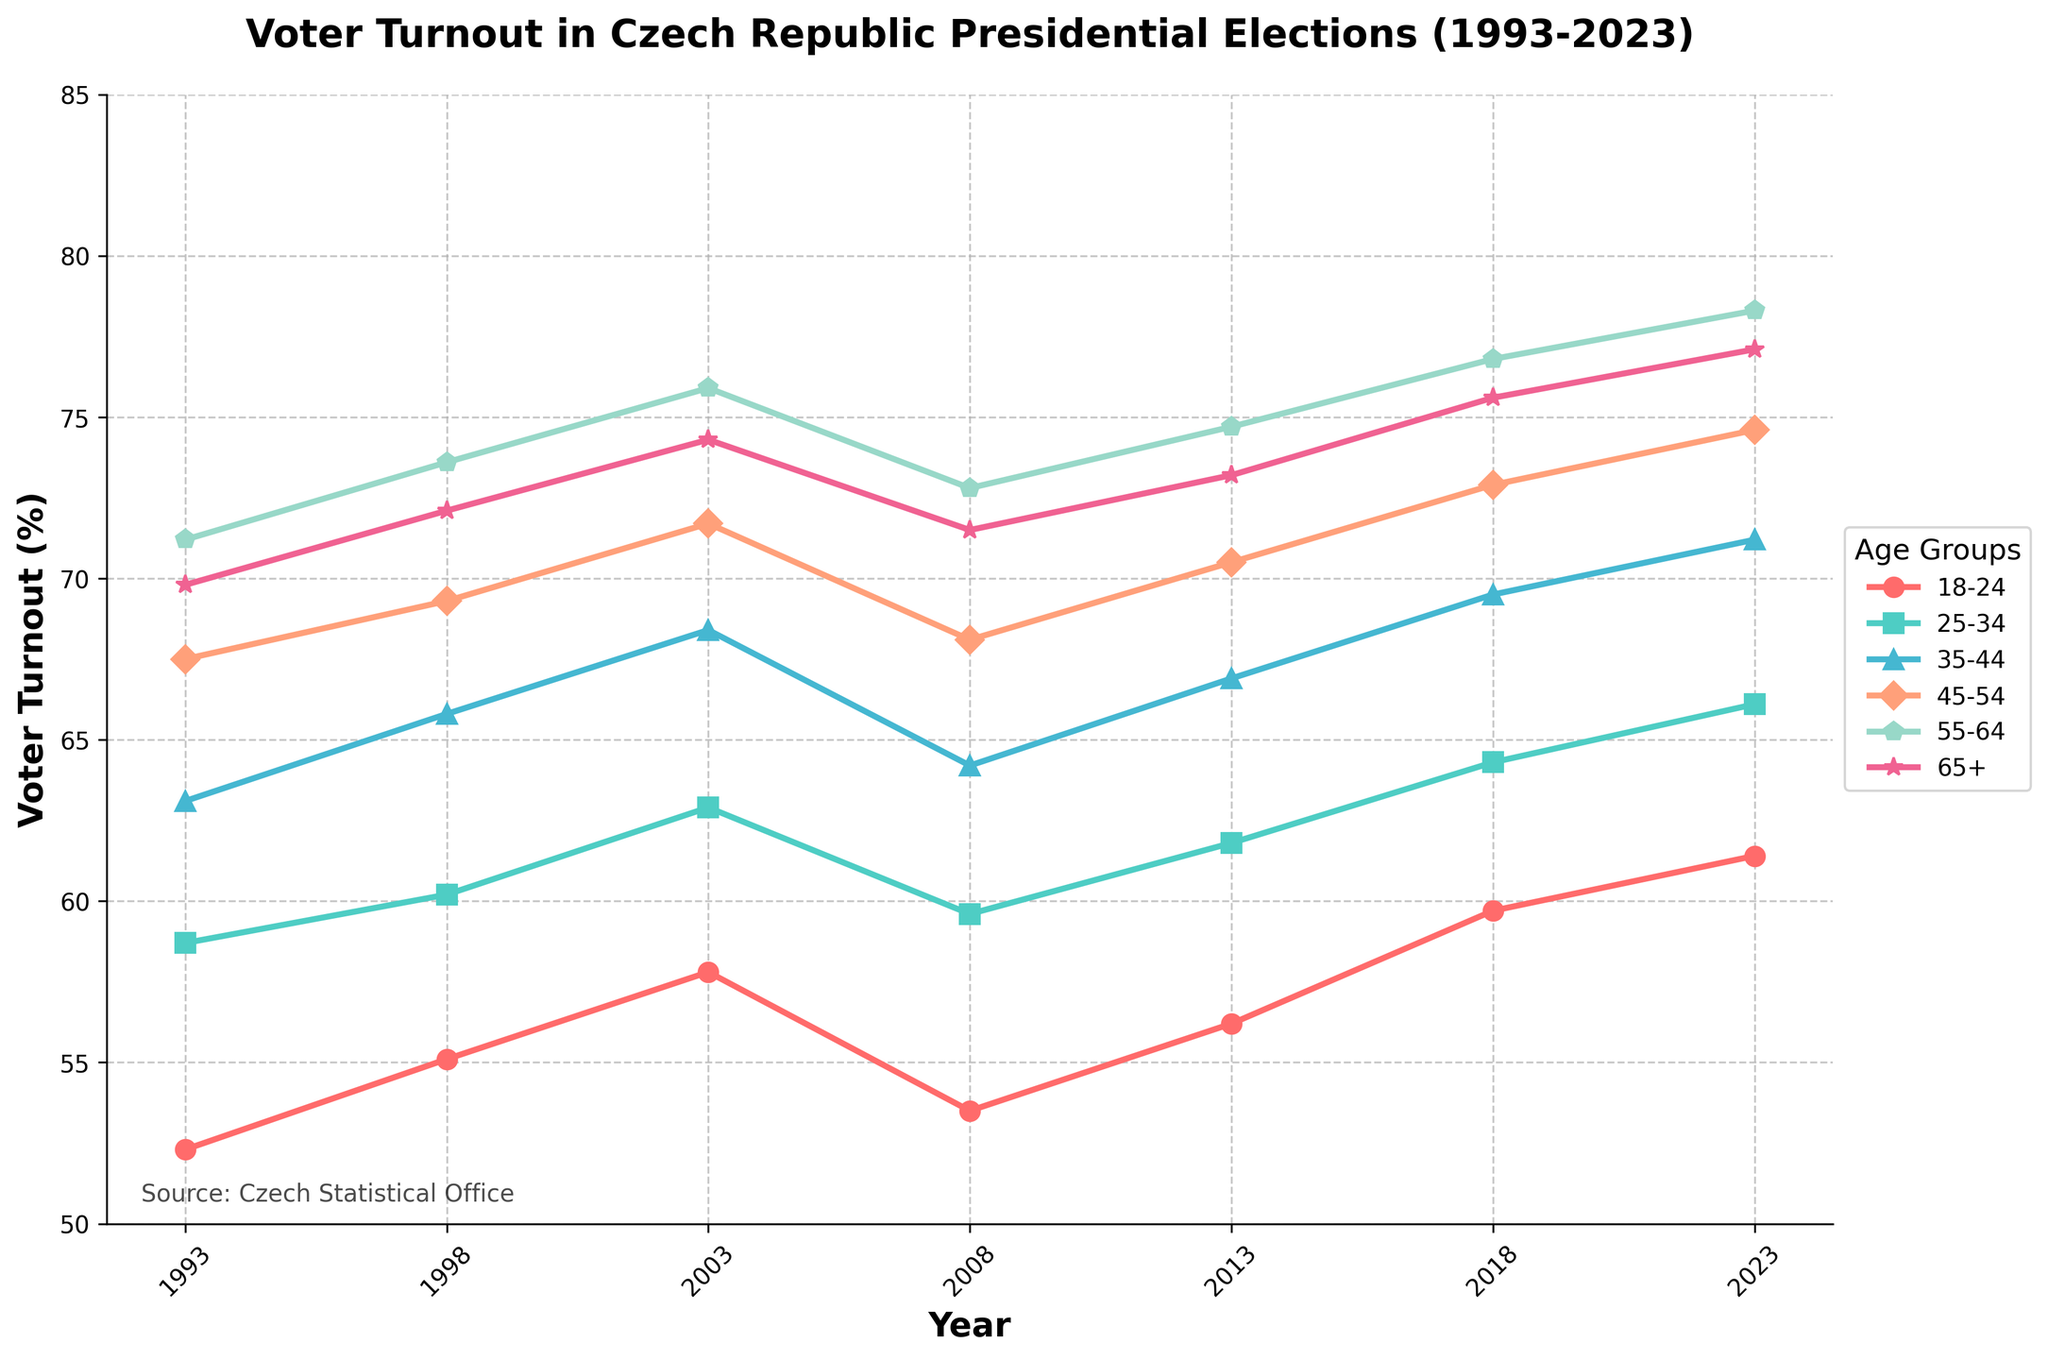What's the trend in voter turnout for the 18-24 age group from 1993 to 2023? The trend can be observed by looking at the plotted points for the 18-24 age group across the years. The turnout starts at 52.3% in 1993, increases to 61.4% by 2023. This indicates an overall upward trend despite some fluctuations.
Answer: Upward trend Between which years did the 55-64 age group see the largest increase in voter turnout? By comparing the increase in percentages year-by-year for the 55-64 age group, the biggest jump can be observed between 2008 (72.8%) and 2013 (74.7%), resulting in an increase of 1.9 percentage points.
Answer: Between 2008 and 2013 What's the average voter turnout for the 65+ age group from 1993 to 2023? To find the average, add the voter turnout percentages for the 65+ age group for each election year (69.8 + 72.1 + 74.3 + 71.5 + 73.2 + 75.6 + 77.1) and then divide by the number of years (7). The calculation is 513.6 / 7 = 73.37%.
Answer: 73.37% Which age group had the lowest voter turnout in 2013? By looking at the 2013 data points for each age group, the 18-24 age group had the lowest voter turnout at 56.2%.
Answer: 18-24 age group Compare the voter turnout between the 35-44 and 45-54 age groups in 1998. Which group had a higher turnout and by how much? In 1998, the voter turnout for the 35-44 age group was 65.8%, and for the 45-54 age group, it was 69.3%. The difference is 69.3% - 65.8% = 3.5%. Therefore, the 45-54 age group had a higher turnout by 3.5%.
Answer: 45-54 by 3.5% How does the voter turnout for the 25-34 age group in 2023 compare to the 55-64 age group in 2003? The voter turnout for the 25-34 age group in 2023 is 66.1%, while for the 55-64 age group in 2003, it is 75.9%. Comparatively, the 55-64 age group in 2003 had a higher turnout by 9.8 percentage points.
Answer: 55-64 in 2003 had a higher turnout by 9.8% From the visual perspective, which age group consistently shows the highest voter turnout between 1993 and 2023? By observing the top-most lines in the plot throughout the years, the 65+ age group consistently shows the highest voter turnout.
Answer: 65+ age group In which election year did the 18-24 age group experience a decline in voter turnout compared to the previous election? By checking the data points for each election year, the 18-24 age group experienced a decline in voter turnout from 2003 (57.8%) to 2008 (53.5%).
Answer: 2008 What is the median voter turnout percentage for all age groups in 2023? List the voter turnout percentages for all age groups in 2023, which are: 61.4%, 66.1%, 71.2%, 74.6%, 78.3%, and 77.1%. To find the median, order these values: 61.4%, 66.1%, 71.2%, 74.6%, 77.1%, 78.3%. The median is the average of the middle two numbers, (71.2% + 74.6%) / 2 = 72.9%.
Answer: 72.9% 